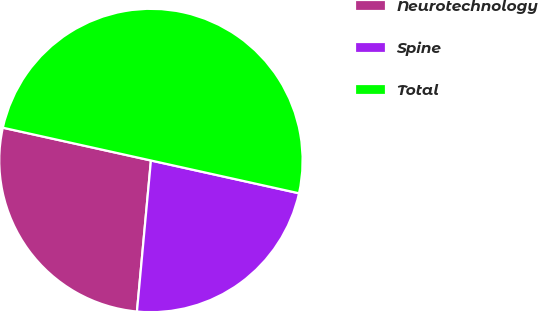Convert chart. <chart><loc_0><loc_0><loc_500><loc_500><pie_chart><fcel>Neurotechnology<fcel>Spine<fcel>Total<nl><fcel>27.0%<fcel>23.0%<fcel>50.0%<nl></chart> 